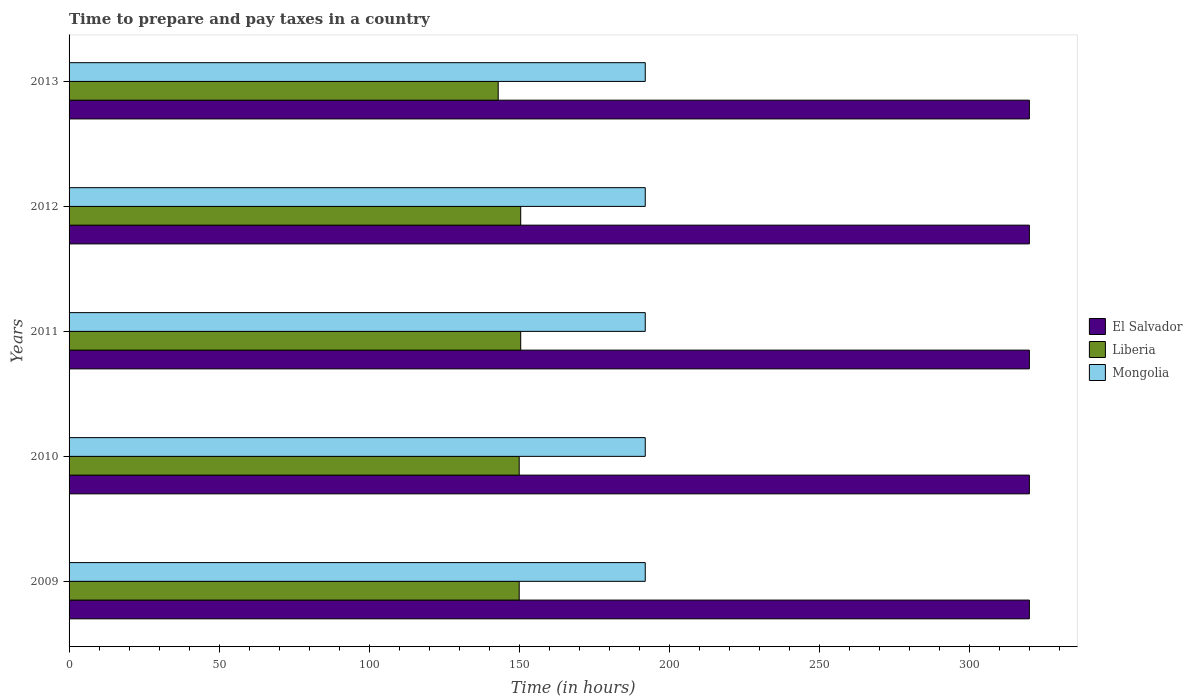Are the number of bars on each tick of the Y-axis equal?
Ensure brevity in your answer.  Yes. What is the label of the 2nd group of bars from the top?
Offer a terse response. 2012. What is the number of hours required to prepare and pay taxes in Mongolia in 2013?
Your response must be concise. 192. Across all years, what is the maximum number of hours required to prepare and pay taxes in Liberia?
Your response must be concise. 150.5. Across all years, what is the minimum number of hours required to prepare and pay taxes in Mongolia?
Make the answer very short. 192. In which year was the number of hours required to prepare and pay taxes in Mongolia minimum?
Keep it short and to the point. 2009. What is the total number of hours required to prepare and pay taxes in El Salvador in the graph?
Give a very brief answer. 1600. What is the difference between the number of hours required to prepare and pay taxes in Liberia in 2009 and that in 2011?
Provide a short and direct response. -0.5. What is the difference between the number of hours required to prepare and pay taxes in Mongolia in 2013 and the number of hours required to prepare and pay taxes in Liberia in 2012?
Your answer should be very brief. 41.5. What is the average number of hours required to prepare and pay taxes in El Salvador per year?
Provide a short and direct response. 320. In the year 2013, what is the difference between the number of hours required to prepare and pay taxes in Mongolia and number of hours required to prepare and pay taxes in Liberia?
Keep it short and to the point. 49. What is the ratio of the number of hours required to prepare and pay taxes in Mongolia in 2010 to that in 2013?
Provide a short and direct response. 1. Is the number of hours required to prepare and pay taxes in Liberia in 2011 less than that in 2012?
Your answer should be very brief. No. Is the difference between the number of hours required to prepare and pay taxes in Mongolia in 2012 and 2013 greater than the difference between the number of hours required to prepare and pay taxes in Liberia in 2012 and 2013?
Your response must be concise. No. Is the sum of the number of hours required to prepare and pay taxes in Mongolia in 2011 and 2012 greater than the maximum number of hours required to prepare and pay taxes in El Salvador across all years?
Offer a terse response. Yes. What does the 3rd bar from the top in 2012 represents?
Provide a short and direct response. El Salvador. What does the 1st bar from the bottom in 2010 represents?
Offer a very short reply. El Salvador. Is it the case that in every year, the sum of the number of hours required to prepare and pay taxes in Mongolia and number of hours required to prepare and pay taxes in El Salvador is greater than the number of hours required to prepare and pay taxes in Liberia?
Your response must be concise. Yes. How many bars are there?
Provide a short and direct response. 15. How many years are there in the graph?
Provide a succinct answer. 5. What is the difference between two consecutive major ticks on the X-axis?
Ensure brevity in your answer.  50. Does the graph contain any zero values?
Ensure brevity in your answer.  No. Does the graph contain grids?
Provide a succinct answer. No. Where does the legend appear in the graph?
Keep it short and to the point. Center right. How many legend labels are there?
Keep it short and to the point. 3. What is the title of the graph?
Provide a succinct answer. Time to prepare and pay taxes in a country. What is the label or title of the X-axis?
Give a very brief answer. Time (in hours). What is the Time (in hours) of El Salvador in 2009?
Ensure brevity in your answer.  320. What is the Time (in hours) of Liberia in 2009?
Your answer should be very brief. 150. What is the Time (in hours) in Mongolia in 2009?
Offer a terse response. 192. What is the Time (in hours) of El Salvador in 2010?
Your answer should be compact. 320. What is the Time (in hours) of Liberia in 2010?
Keep it short and to the point. 150. What is the Time (in hours) in Mongolia in 2010?
Make the answer very short. 192. What is the Time (in hours) of El Salvador in 2011?
Your answer should be compact. 320. What is the Time (in hours) of Liberia in 2011?
Offer a very short reply. 150.5. What is the Time (in hours) in Mongolia in 2011?
Your response must be concise. 192. What is the Time (in hours) in El Salvador in 2012?
Make the answer very short. 320. What is the Time (in hours) in Liberia in 2012?
Ensure brevity in your answer.  150.5. What is the Time (in hours) in Mongolia in 2012?
Provide a succinct answer. 192. What is the Time (in hours) of El Salvador in 2013?
Provide a succinct answer. 320. What is the Time (in hours) of Liberia in 2013?
Provide a short and direct response. 143. What is the Time (in hours) of Mongolia in 2013?
Make the answer very short. 192. Across all years, what is the maximum Time (in hours) in El Salvador?
Offer a very short reply. 320. Across all years, what is the maximum Time (in hours) of Liberia?
Provide a succinct answer. 150.5. Across all years, what is the maximum Time (in hours) of Mongolia?
Offer a very short reply. 192. Across all years, what is the minimum Time (in hours) of El Salvador?
Your answer should be compact. 320. Across all years, what is the minimum Time (in hours) in Liberia?
Offer a terse response. 143. Across all years, what is the minimum Time (in hours) of Mongolia?
Offer a terse response. 192. What is the total Time (in hours) in El Salvador in the graph?
Offer a terse response. 1600. What is the total Time (in hours) of Liberia in the graph?
Provide a succinct answer. 744. What is the total Time (in hours) in Mongolia in the graph?
Your response must be concise. 960. What is the difference between the Time (in hours) in Liberia in 2009 and that in 2010?
Your answer should be compact. 0. What is the difference between the Time (in hours) in Liberia in 2009 and that in 2011?
Ensure brevity in your answer.  -0.5. What is the difference between the Time (in hours) in Mongolia in 2009 and that in 2011?
Make the answer very short. 0. What is the difference between the Time (in hours) in El Salvador in 2009 and that in 2012?
Offer a very short reply. 0. What is the difference between the Time (in hours) in Mongolia in 2009 and that in 2012?
Offer a terse response. 0. What is the difference between the Time (in hours) in El Salvador in 2009 and that in 2013?
Your answer should be compact. 0. What is the difference between the Time (in hours) of Liberia in 2009 and that in 2013?
Your answer should be very brief. 7. What is the difference between the Time (in hours) in El Salvador in 2010 and that in 2011?
Your answer should be compact. 0. What is the difference between the Time (in hours) of Liberia in 2010 and that in 2011?
Offer a very short reply. -0.5. What is the difference between the Time (in hours) in Mongolia in 2010 and that in 2011?
Provide a succinct answer. 0. What is the difference between the Time (in hours) of Mongolia in 2010 and that in 2012?
Offer a terse response. 0. What is the difference between the Time (in hours) of El Salvador in 2010 and that in 2013?
Offer a very short reply. 0. What is the difference between the Time (in hours) of Liberia in 2010 and that in 2013?
Your response must be concise. 7. What is the difference between the Time (in hours) of Mongolia in 2010 and that in 2013?
Offer a very short reply. 0. What is the difference between the Time (in hours) of El Salvador in 2011 and that in 2012?
Your answer should be very brief. 0. What is the difference between the Time (in hours) in Mongolia in 2011 and that in 2012?
Your answer should be compact. 0. What is the difference between the Time (in hours) in Liberia in 2012 and that in 2013?
Offer a very short reply. 7.5. What is the difference between the Time (in hours) in Mongolia in 2012 and that in 2013?
Your answer should be compact. 0. What is the difference between the Time (in hours) in El Salvador in 2009 and the Time (in hours) in Liberia in 2010?
Ensure brevity in your answer.  170. What is the difference between the Time (in hours) in El Salvador in 2009 and the Time (in hours) in Mongolia in 2010?
Provide a short and direct response. 128. What is the difference between the Time (in hours) of Liberia in 2009 and the Time (in hours) of Mongolia in 2010?
Give a very brief answer. -42. What is the difference between the Time (in hours) in El Salvador in 2009 and the Time (in hours) in Liberia in 2011?
Offer a terse response. 169.5. What is the difference between the Time (in hours) in El Salvador in 2009 and the Time (in hours) in Mongolia in 2011?
Keep it short and to the point. 128. What is the difference between the Time (in hours) in Liberia in 2009 and the Time (in hours) in Mongolia in 2011?
Keep it short and to the point. -42. What is the difference between the Time (in hours) of El Salvador in 2009 and the Time (in hours) of Liberia in 2012?
Ensure brevity in your answer.  169.5. What is the difference between the Time (in hours) of El Salvador in 2009 and the Time (in hours) of Mongolia in 2012?
Your response must be concise. 128. What is the difference between the Time (in hours) of Liberia in 2009 and the Time (in hours) of Mongolia in 2012?
Offer a terse response. -42. What is the difference between the Time (in hours) in El Salvador in 2009 and the Time (in hours) in Liberia in 2013?
Your answer should be very brief. 177. What is the difference between the Time (in hours) of El Salvador in 2009 and the Time (in hours) of Mongolia in 2013?
Keep it short and to the point. 128. What is the difference between the Time (in hours) in Liberia in 2009 and the Time (in hours) in Mongolia in 2013?
Offer a terse response. -42. What is the difference between the Time (in hours) of El Salvador in 2010 and the Time (in hours) of Liberia in 2011?
Your answer should be very brief. 169.5. What is the difference between the Time (in hours) in El Salvador in 2010 and the Time (in hours) in Mongolia in 2011?
Your answer should be compact. 128. What is the difference between the Time (in hours) of Liberia in 2010 and the Time (in hours) of Mongolia in 2011?
Your response must be concise. -42. What is the difference between the Time (in hours) in El Salvador in 2010 and the Time (in hours) in Liberia in 2012?
Provide a short and direct response. 169.5. What is the difference between the Time (in hours) of El Salvador in 2010 and the Time (in hours) of Mongolia in 2012?
Offer a very short reply. 128. What is the difference between the Time (in hours) of Liberia in 2010 and the Time (in hours) of Mongolia in 2012?
Your answer should be very brief. -42. What is the difference between the Time (in hours) in El Salvador in 2010 and the Time (in hours) in Liberia in 2013?
Offer a terse response. 177. What is the difference between the Time (in hours) in El Salvador in 2010 and the Time (in hours) in Mongolia in 2013?
Provide a succinct answer. 128. What is the difference between the Time (in hours) of Liberia in 2010 and the Time (in hours) of Mongolia in 2013?
Offer a very short reply. -42. What is the difference between the Time (in hours) in El Salvador in 2011 and the Time (in hours) in Liberia in 2012?
Keep it short and to the point. 169.5. What is the difference between the Time (in hours) of El Salvador in 2011 and the Time (in hours) of Mongolia in 2012?
Your answer should be compact. 128. What is the difference between the Time (in hours) in Liberia in 2011 and the Time (in hours) in Mongolia in 2012?
Ensure brevity in your answer.  -41.5. What is the difference between the Time (in hours) of El Salvador in 2011 and the Time (in hours) of Liberia in 2013?
Make the answer very short. 177. What is the difference between the Time (in hours) of El Salvador in 2011 and the Time (in hours) of Mongolia in 2013?
Offer a terse response. 128. What is the difference between the Time (in hours) of Liberia in 2011 and the Time (in hours) of Mongolia in 2013?
Your answer should be compact. -41.5. What is the difference between the Time (in hours) of El Salvador in 2012 and the Time (in hours) of Liberia in 2013?
Your answer should be compact. 177. What is the difference between the Time (in hours) in El Salvador in 2012 and the Time (in hours) in Mongolia in 2013?
Keep it short and to the point. 128. What is the difference between the Time (in hours) in Liberia in 2012 and the Time (in hours) in Mongolia in 2013?
Offer a very short reply. -41.5. What is the average Time (in hours) of El Salvador per year?
Your answer should be very brief. 320. What is the average Time (in hours) of Liberia per year?
Your answer should be very brief. 148.8. What is the average Time (in hours) in Mongolia per year?
Ensure brevity in your answer.  192. In the year 2009, what is the difference between the Time (in hours) in El Salvador and Time (in hours) in Liberia?
Provide a short and direct response. 170. In the year 2009, what is the difference between the Time (in hours) in El Salvador and Time (in hours) in Mongolia?
Make the answer very short. 128. In the year 2009, what is the difference between the Time (in hours) in Liberia and Time (in hours) in Mongolia?
Provide a succinct answer. -42. In the year 2010, what is the difference between the Time (in hours) of El Salvador and Time (in hours) of Liberia?
Your response must be concise. 170. In the year 2010, what is the difference between the Time (in hours) in El Salvador and Time (in hours) in Mongolia?
Your answer should be very brief. 128. In the year 2010, what is the difference between the Time (in hours) in Liberia and Time (in hours) in Mongolia?
Offer a terse response. -42. In the year 2011, what is the difference between the Time (in hours) of El Salvador and Time (in hours) of Liberia?
Give a very brief answer. 169.5. In the year 2011, what is the difference between the Time (in hours) of El Salvador and Time (in hours) of Mongolia?
Your response must be concise. 128. In the year 2011, what is the difference between the Time (in hours) in Liberia and Time (in hours) in Mongolia?
Give a very brief answer. -41.5. In the year 2012, what is the difference between the Time (in hours) of El Salvador and Time (in hours) of Liberia?
Provide a succinct answer. 169.5. In the year 2012, what is the difference between the Time (in hours) in El Salvador and Time (in hours) in Mongolia?
Make the answer very short. 128. In the year 2012, what is the difference between the Time (in hours) in Liberia and Time (in hours) in Mongolia?
Keep it short and to the point. -41.5. In the year 2013, what is the difference between the Time (in hours) in El Salvador and Time (in hours) in Liberia?
Offer a terse response. 177. In the year 2013, what is the difference between the Time (in hours) of El Salvador and Time (in hours) of Mongolia?
Provide a succinct answer. 128. In the year 2013, what is the difference between the Time (in hours) in Liberia and Time (in hours) in Mongolia?
Keep it short and to the point. -49. What is the ratio of the Time (in hours) in Liberia in 2009 to that in 2010?
Make the answer very short. 1. What is the ratio of the Time (in hours) in El Salvador in 2009 to that in 2011?
Provide a short and direct response. 1. What is the ratio of the Time (in hours) in Mongolia in 2009 to that in 2011?
Keep it short and to the point. 1. What is the ratio of the Time (in hours) of El Salvador in 2009 to that in 2013?
Give a very brief answer. 1. What is the ratio of the Time (in hours) in Liberia in 2009 to that in 2013?
Provide a short and direct response. 1.05. What is the ratio of the Time (in hours) of Mongolia in 2009 to that in 2013?
Make the answer very short. 1. What is the ratio of the Time (in hours) of El Salvador in 2010 to that in 2011?
Keep it short and to the point. 1. What is the ratio of the Time (in hours) of Liberia in 2010 to that in 2011?
Your response must be concise. 1. What is the ratio of the Time (in hours) in El Salvador in 2010 to that in 2012?
Offer a terse response. 1. What is the ratio of the Time (in hours) of Liberia in 2010 to that in 2013?
Offer a very short reply. 1.05. What is the ratio of the Time (in hours) in El Salvador in 2011 to that in 2012?
Offer a very short reply. 1. What is the ratio of the Time (in hours) in Liberia in 2011 to that in 2012?
Keep it short and to the point. 1. What is the ratio of the Time (in hours) in Mongolia in 2011 to that in 2012?
Provide a short and direct response. 1. What is the ratio of the Time (in hours) of El Salvador in 2011 to that in 2013?
Provide a succinct answer. 1. What is the ratio of the Time (in hours) of Liberia in 2011 to that in 2013?
Your answer should be very brief. 1.05. What is the ratio of the Time (in hours) of Liberia in 2012 to that in 2013?
Offer a terse response. 1.05. What is the difference between the highest and the lowest Time (in hours) in Liberia?
Make the answer very short. 7.5. What is the difference between the highest and the lowest Time (in hours) of Mongolia?
Make the answer very short. 0. 